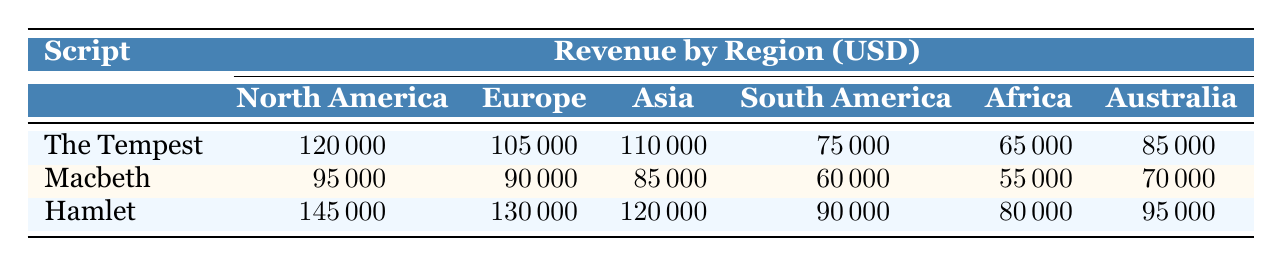What is the revenue generated by "Hamlet" in North America? From the table, the revenue for "Hamlet" in North America is listed directly under the North America column in the Hamlet row, which shows 145000.
Answer: 145000 Which script had the highest sales in Europe? In the Europe column, the revenues for each script are: "The Tempest" 105000, "Macbeth" 90000, and "Hamlet" 130000. The highest among these is 130000 for "Hamlet".
Answer: Hamlet What is the total revenue generated by "The Tempest" across all regions? To find the total revenue for "The Tempest", I will add the revenues across all regions: North America (120000) + Europe (105000) + Asia (110000) + South America (75000) + Africa (65000) + Australia (85000) = 120000 + 105000 + 110000 + 75000 + 65000 + 85000 = 600000.
Answer: 600000 Is the revenue from "Macbeth" in Asia higher than in South America? The revenue for "Macbeth" in Asia is 85000, while in South America it is 60000. Since 85000 is greater than 60000, the statement is true.
Answer: Yes What is the average revenue of "Hamlet" across all regions? The revenues for "Hamlet" in each region are: North America (145000), Europe (130000), Asia (120000), South America (90000), Africa (80000), and Australia (95000). I will sum them: 145000 + 130000 + 120000 + 90000 + 80000 + 95000 = 720000. Then, divide by the number of regions (6): 720000 / 6 = 120000.
Answer: 120000 Which region has the lowest revenue for "Macbeth"? From the table, the revenues for "Macbeth" are: North America (95000), Europe (90000), Asia (85000), South America (60000), Africa (55000), and Australia (70000). The lowest value is found in Africa, which is 55000.
Answer: Africa If you combine the revenues of "The Tempest" and "Hamlet" in Australia, what is the total? In Australia, "The Tempest" revenue is 85000 and "Hamlet" revenue is 95000. Adding these amounts: 85000 + 95000 = 180000.
Answer: 180000 What is the difference between "Hamlet" sales in North America and "Macbeth" sales in Europe? The revenue for "Hamlet" in North America is 145000, and for "Macbeth" in Europe it is 90000. To find the difference, I subtract: 145000 - 90000 = 55000.
Answer: 55000 